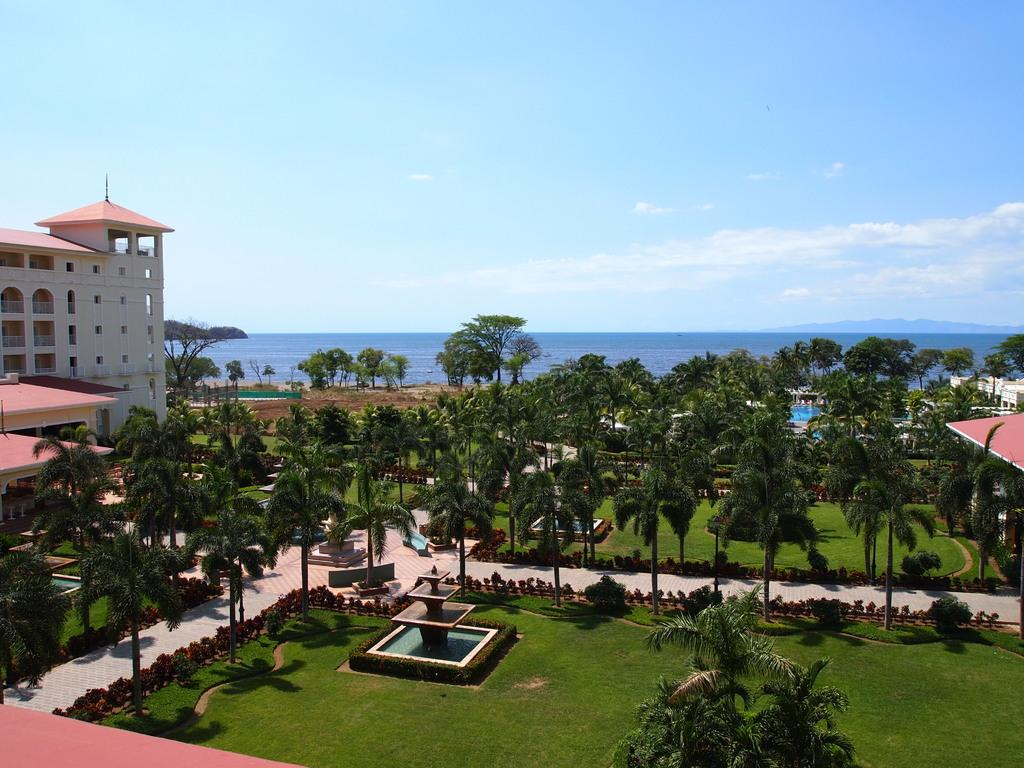What type of structures can be seen on the sides of the image? There are buildings on either side of the image. What is present on the ground in the image? There is greenery on the ground in the image. What type of vegetation is visible in the image? There are trees in the image. What can be seen in the background of the image? There is water visible in the background of the image. Can you see any dust particles floating in the air in the image? There is no mention of dust particles in the image, so we cannot determine their presence. Is there a gun visible in the image? There is no mention of a gun in the image, so we cannot determine its presence. 